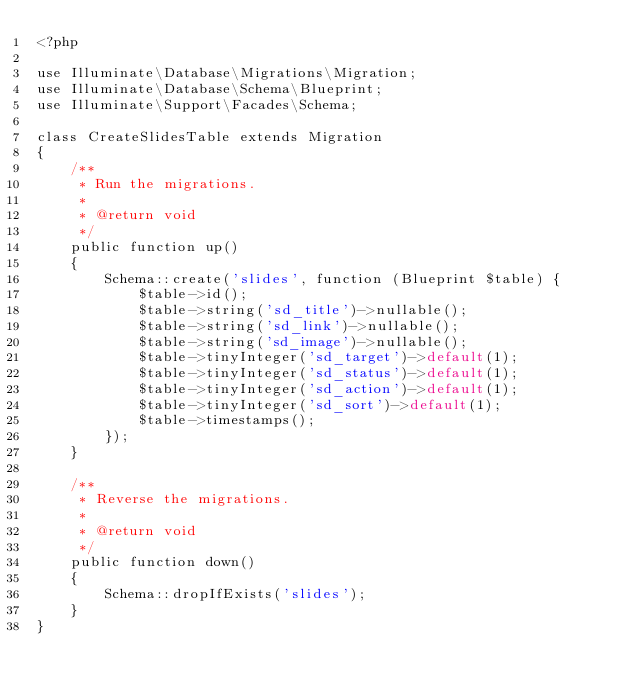<code> <loc_0><loc_0><loc_500><loc_500><_PHP_><?php

use Illuminate\Database\Migrations\Migration;
use Illuminate\Database\Schema\Blueprint;
use Illuminate\Support\Facades\Schema;

class CreateSlidesTable extends Migration
{
    /**
     * Run the migrations.
     *
     * @return void
     */
    public function up()
    {
        Schema::create('slides', function (Blueprint $table) {
            $table->id();
            $table->string('sd_title')->nullable();
            $table->string('sd_link')->nullable();
            $table->string('sd_image')->nullable();
            $table->tinyInteger('sd_target')->default(1);
            $table->tinyInteger('sd_status')->default(1);
            $table->tinyInteger('sd_action')->default(1);
            $table->tinyInteger('sd_sort')->default(1);
            $table->timestamps();
        });
    }

    /**
     * Reverse the migrations.
     *
     * @return void
     */
    public function down()
    {
        Schema::dropIfExists('slides');
    }
}
</code> 